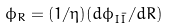<formula> <loc_0><loc_0><loc_500><loc_500>\phi _ { R } = ( 1 / \eta ) ( d \phi _ { I \bar { I } } / d R )</formula> 